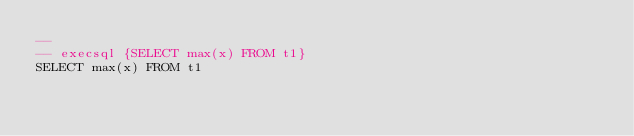<code> <loc_0><loc_0><loc_500><loc_500><_SQL_>-- 
-- execsql {SELECT max(x) FROM t1}
SELECT max(x) FROM t1</code> 